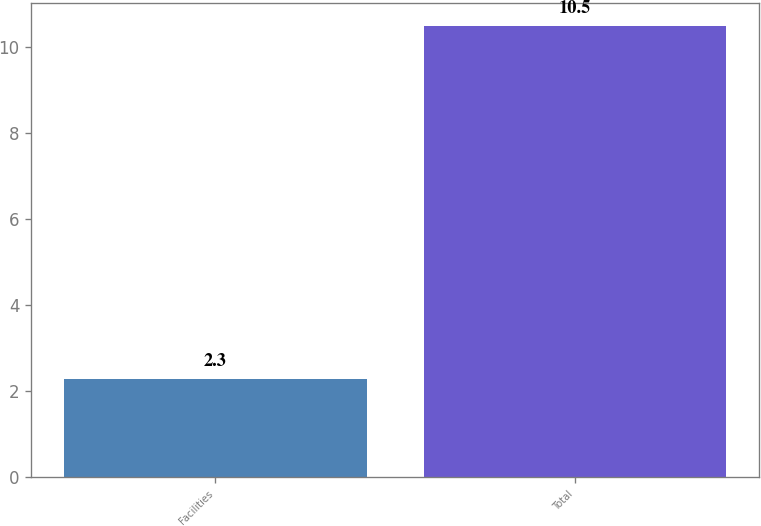<chart> <loc_0><loc_0><loc_500><loc_500><bar_chart><fcel>Facilities<fcel>Total<nl><fcel>2.3<fcel>10.5<nl></chart> 